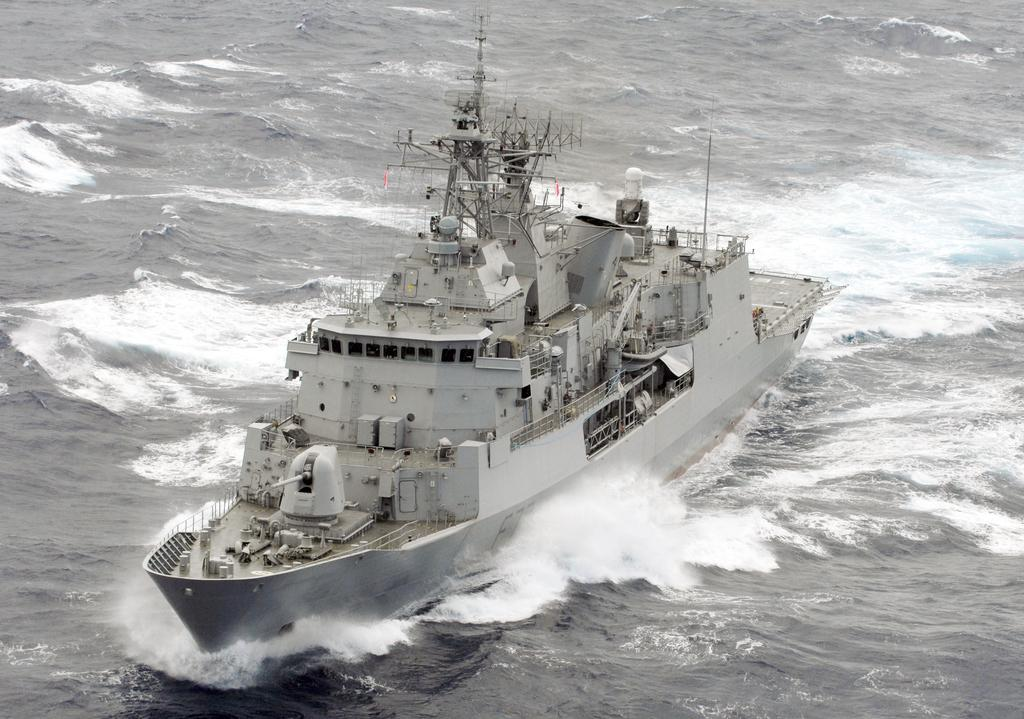What is the color scheme of the image? The image is black and white. What is the main subject of the image? There is a ship in the image. Where is the ship located? The ship is on the sea. What type of produce can be seen growing near the ship in the image? There is no produce visible in the image, as it is a black and white image of a ship on the sea. 